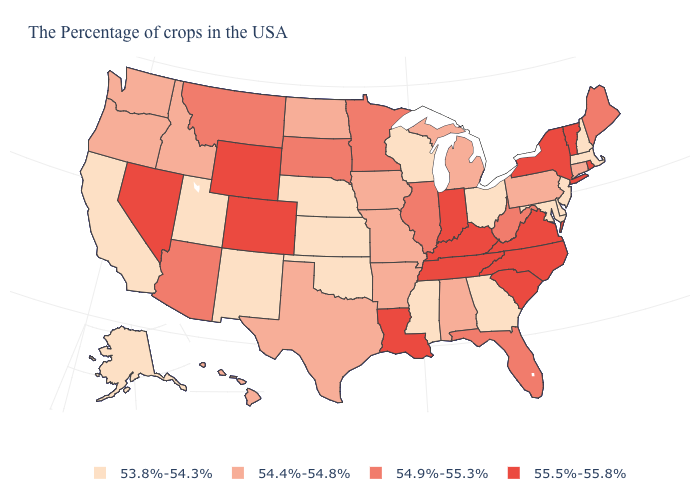Which states hav the highest value in the MidWest?
Quick response, please. Indiana. What is the value of North Carolina?
Be succinct. 55.5%-55.8%. What is the value of Alaska?
Quick response, please. 53.8%-54.3%. What is the value of Nevada?
Quick response, please. 55.5%-55.8%. Name the states that have a value in the range 54.9%-55.3%?
Short answer required. Maine, West Virginia, Florida, Illinois, Minnesota, South Dakota, Montana, Arizona. What is the value of Louisiana?
Answer briefly. 55.5%-55.8%. What is the value of Wisconsin?
Keep it brief. 53.8%-54.3%. Does the first symbol in the legend represent the smallest category?
Be succinct. Yes. What is the value of Nevada?
Keep it brief. 55.5%-55.8%. What is the lowest value in the West?
Answer briefly. 53.8%-54.3%. Does Alaska have the highest value in the West?
Answer briefly. No. Name the states that have a value in the range 54.4%-54.8%?
Keep it brief. Connecticut, Pennsylvania, Michigan, Alabama, Missouri, Arkansas, Iowa, Texas, North Dakota, Idaho, Washington, Oregon, Hawaii. What is the value of Louisiana?
Write a very short answer. 55.5%-55.8%. What is the value of Montana?
Answer briefly. 54.9%-55.3%. Which states have the highest value in the USA?
Concise answer only. Rhode Island, Vermont, New York, Virginia, North Carolina, South Carolina, Kentucky, Indiana, Tennessee, Louisiana, Wyoming, Colorado, Nevada. 